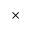<formula> <loc_0><loc_0><loc_500><loc_500>\times</formula> 